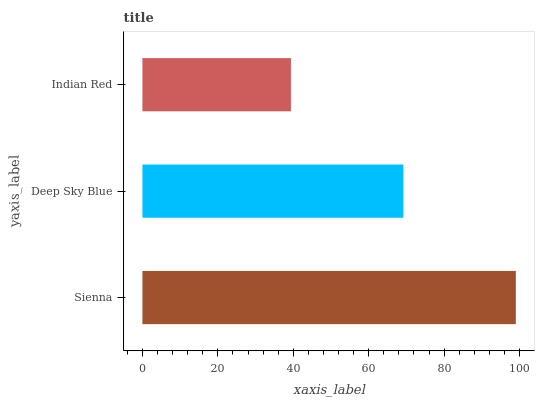Is Indian Red the minimum?
Answer yes or no. Yes. Is Sienna the maximum?
Answer yes or no. Yes. Is Deep Sky Blue the minimum?
Answer yes or no. No. Is Deep Sky Blue the maximum?
Answer yes or no. No. Is Sienna greater than Deep Sky Blue?
Answer yes or no. Yes. Is Deep Sky Blue less than Sienna?
Answer yes or no. Yes. Is Deep Sky Blue greater than Sienna?
Answer yes or no. No. Is Sienna less than Deep Sky Blue?
Answer yes or no. No. Is Deep Sky Blue the high median?
Answer yes or no. Yes. Is Deep Sky Blue the low median?
Answer yes or no. Yes. Is Indian Red the high median?
Answer yes or no. No. Is Sienna the low median?
Answer yes or no. No. 